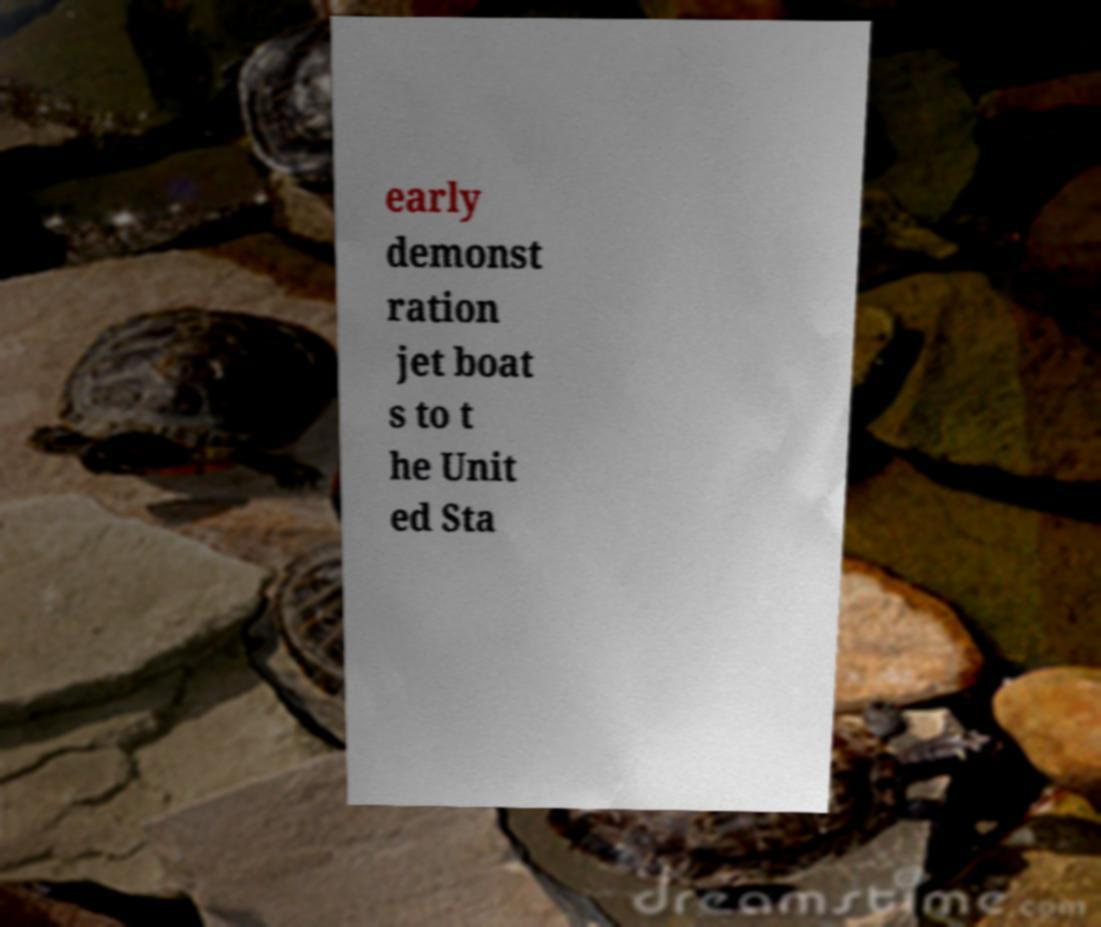I need the written content from this picture converted into text. Can you do that? early demonst ration jet boat s to t he Unit ed Sta 